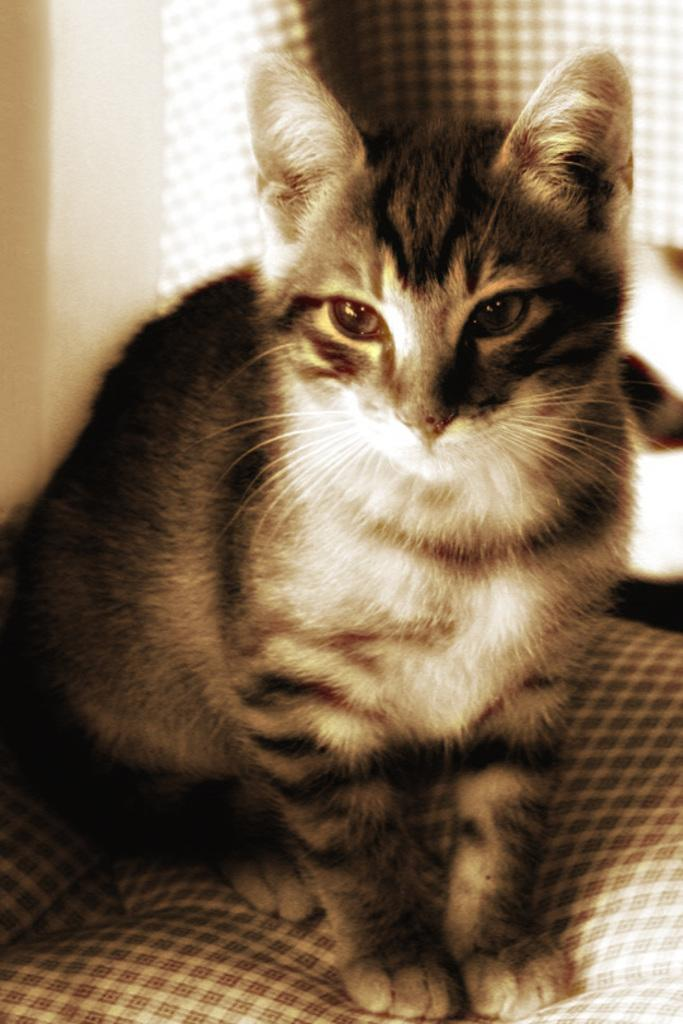What type of animal is in the image? There is a cat in the image. What is the cat sitting on? The cat is sitting on a couch. What is visible beside the cat? There is a wall beside the cat. What type of guitar is the cat playing in the image? There is no guitar present in the image; it features a cat sitting on a couch. Can you see any patches on the cat's fur in the image? There is no mention of patches on the cat's fur in the provided facts, so it cannot be determined from the image. 